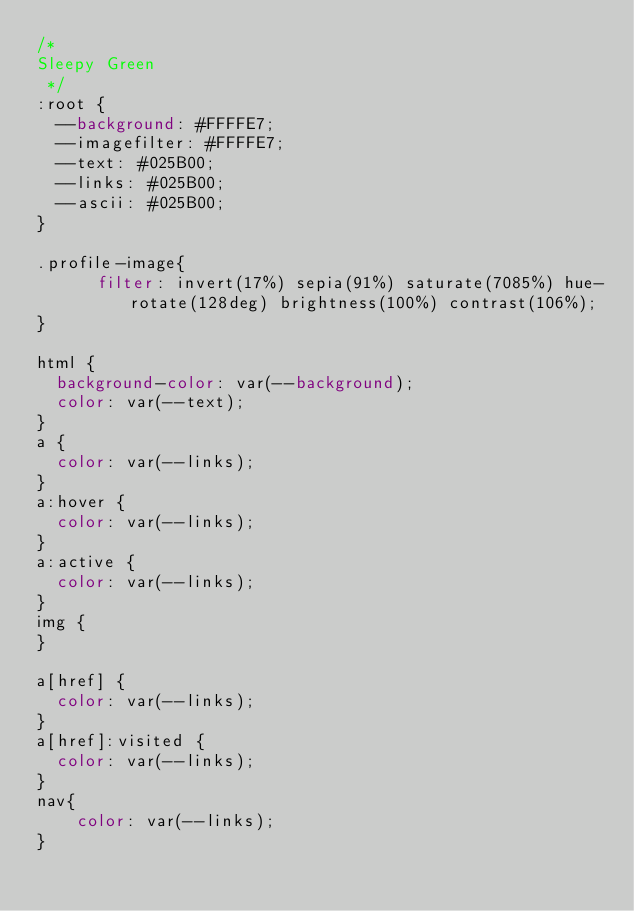Convert code to text. <code><loc_0><loc_0><loc_500><loc_500><_CSS_>/* 
Sleepy Green
 */
:root {
  --background: #FFFFE7;
  --imagefilter: #FFFFE7;
  --text: #025B00;
  --links: #025B00;
  --ascii: #025B00;
}

.profile-image{
      filter: invert(17%) sepia(91%) saturate(7085%) hue-rotate(128deg) brightness(100%) contrast(106%);
}

html {
  background-color: var(--background);
  color: var(--text);
}
a {
  color: var(--links);
}
a:hover {
  color: var(--links);
}
a:active {
  color: var(--links);
}
img {
}

a[href] {
  color: var(--links);
}
a[href]:visited {
  color: var(--links);
}
nav{
    color: var(--links);
}</code> 